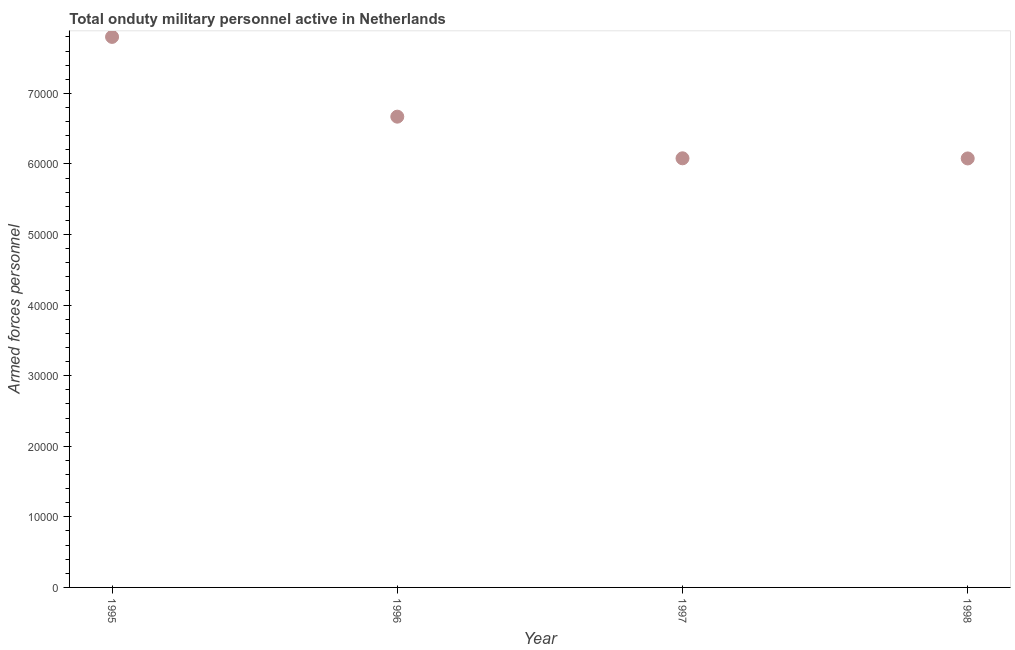What is the number of armed forces personnel in 1995?
Provide a short and direct response. 7.80e+04. Across all years, what is the maximum number of armed forces personnel?
Keep it short and to the point. 7.80e+04. Across all years, what is the minimum number of armed forces personnel?
Offer a terse response. 6.08e+04. In which year was the number of armed forces personnel minimum?
Give a very brief answer. 1998. What is the sum of the number of armed forces personnel?
Keep it short and to the point. 2.66e+05. What is the difference between the number of armed forces personnel in 1997 and 1998?
Make the answer very short. 20. What is the average number of armed forces personnel per year?
Give a very brief answer. 6.66e+04. What is the median number of armed forces personnel?
Keep it short and to the point. 6.38e+04. In how many years, is the number of armed forces personnel greater than 6000 ?
Your response must be concise. 4. Do a majority of the years between 1997 and 1998 (inclusive) have number of armed forces personnel greater than 62000 ?
Provide a succinct answer. No. What is the ratio of the number of armed forces personnel in 1996 to that in 1998?
Your response must be concise. 1.1. Is the number of armed forces personnel in 1996 less than that in 1998?
Your answer should be very brief. No. Is the difference between the number of armed forces personnel in 1995 and 1996 greater than the difference between any two years?
Your answer should be compact. No. What is the difference between the highest and the second highest number of armed forces personnel?
Offer a very short reply. 1.13e+04. What is the difference between the highest and the lowest number of armed forces personnel?
Your answer should be compact. 1.72e+04. In how many years, is the number of armed forces personnel greater than the average number of armed forces personnel taken over all years?
Make the answer very short. 2. How many years are there in the graph?
Your answer should be very brief. 4. What is the difference between two consecutive major ticks on the Y-axis?
Provide a succinct answer. 10000. Are the values on the major ticks of Y-axis written in scientific E-notation?
Offer a very short reply. No. Does the graph contain any zero values?
Your answer should be compact. No. What is the title of the graph?
Your response must be concise. Total onduty military personnel active in Netherlands. What is the label or title of the Y-axis?
Provide a short and direct response. Armed forces personnel. What is the Armed forces personnel in 1995?
Provide a short and direct response. 7.80e+04. What is the Armed forces personnel in 1996?
Your response must be concise. 6.67e+04. What is the Armed forces personnel in 1997?
Offer a terse response. 6.08e+04. What is the Armed forces personnel in 1998?
Your answer should be very brief. 6.08e+04. What is the difference between the Armed forces personnel in 1995 and 1996?
Keep it short and to the point. 1.13e+04. What is the difference between the Armed forces personnel in 1995 and 1997?
Offer a terse response. 1.72e+04. What is the difference between the Armed forces personnel in 1995 and 1998?
Provide a short and direct response. 1.72e+04. What is the difference between the Armed forces personnel in 1996 and 1997?
Ensure brevity in your answer.  5900. What is the difference between the Armed forces personnel in 1996 and 1998?
Your answer should be very brief. 5920. What is the ratio of the Armed forces personnel in 1995 to that in 1996?
Offer a terse response. 1.17. What is the ratio of the Armed forces personnel in 1995 to that in 1997?
Your answer should be compact. 1.28. What is the ratio of the Armed forces personnel in 1995 to that in 1998?
Provide a succinct answer. 1.28. What is the ratio of the Armed forces personnel in 1996 to that in 1997?
Offer a terse response. 1.1. What is the ratio of the Armed forces personnel in 1996 to that in 1998?
Your response must be concise. 1.1. What is the ratio of the Armed forces personnel in 1997 to that in 1998?
Your response must be concise. 1. 